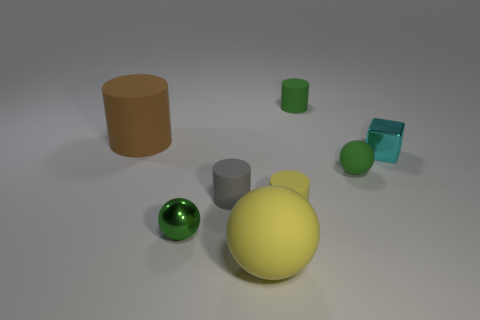Can you tell the texture of the objects? While physical textures cannot be felt through an image, visually the objects appear to have a smooth surface, particularly the green sphere which has a shiny, reflective finish, and the transparent light blue cube which suggests a glass-like material. 